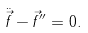<formula> <loc_0><loc_0><loc_500><loc_500>\ddot { \vec { f } } - \vec { f } ^ { \prime \prime } = 0 .</formula> 